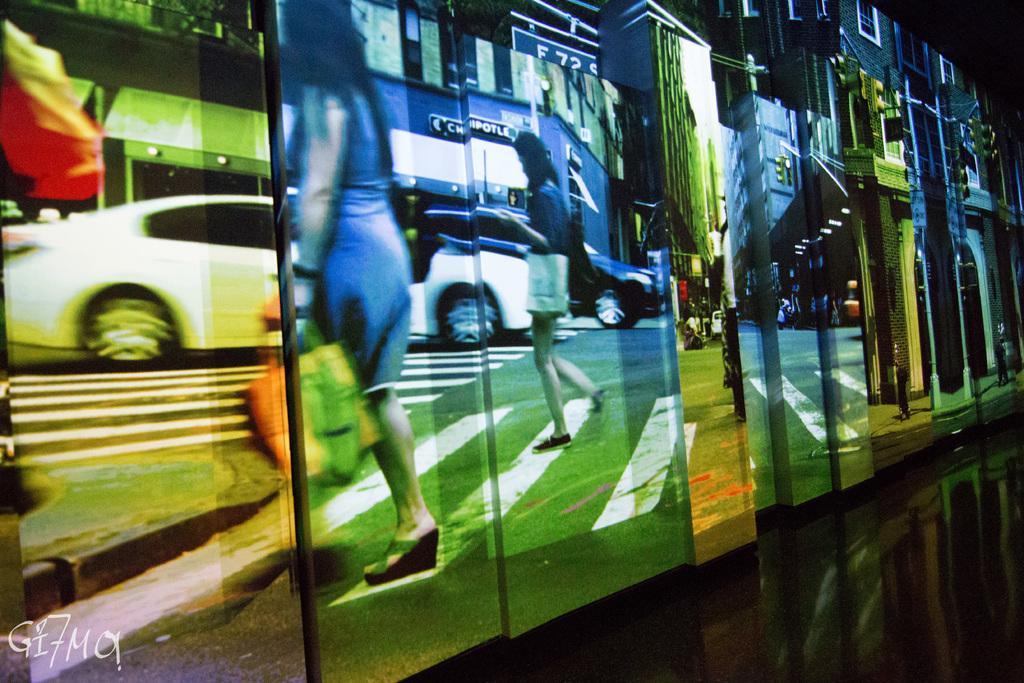Describe this image in one or two sentences. This is an edited image. It seems to be a glass. In the foreground few people are crossing the road. In the background there are few vehicles and buildings. The background is in black color. In the bottom left-hand corner there is a watermark. 